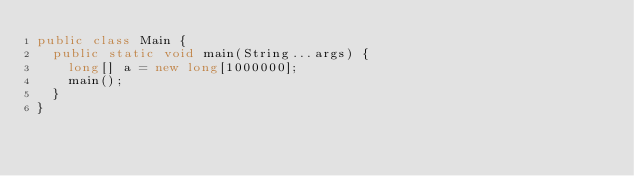<code> <loc_0><loc_0><loc_500><loc_500><_Java_>public class Main {
  public static void main(String...args) {
    long[] a = new long[1000000];
    main();
  }
}
</code> 